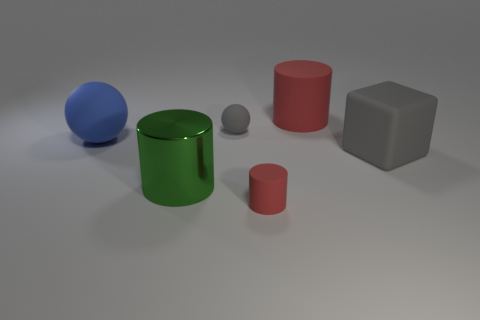Add 4 tiny red matte cylinders. How many objects exist? 10 Subtract all balls. How many objects are left? 4 Add 1 metal objects. How many metal objects are left? 2 Add 6 large metallic objects. How many large metallic objects exist? 7 Subtract 0 yellow cubes. How many objects are left? 6 Subtract all big cyan metallic cylinders. Subtract all large cubes. How many objects are left? 5 